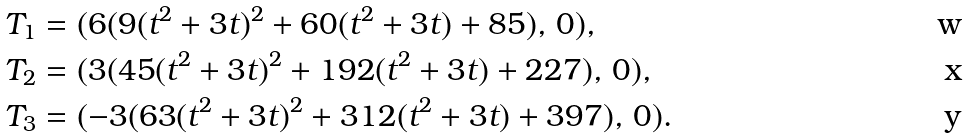<formula> <loc_0><loc_0><loc_500><loc_500>& T _ { 1 } = ( 6 ( 9 ( t ^ { 2 } + 3 t ) ^ { 2 } + 6 0 ( t ^ { 2 } + 3 t ) + 8 5 ) , \, 0 ) , \\ & T _ { 2 } = ( 3 ( 4 5 ( t ^ { 2 } + 3 t ) ^ { 2 } + 1 9 2 ( t ^ { 2 } + 3 t ) + 2 2 7 ) , \, 0 ) , \\ & T _ { 3 } = ( - 3 ( 6 3 ( t ^ { 2 } + 3 t ) ^ { 2 } + 3 1 2 ( t ^ { 2 } + 3 t ) + 3 9 7 ) , \, 0 ) .</formula> 